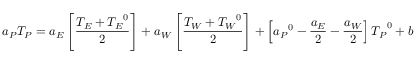Convert formula to latex. <formula><loc_0><loc_0><loc_500><loc_500>a _ { P } T _ { P } = a _ { E } \left [ { \frac { T _ { E } + { T _ { E } } ^ { 0 } } { 2 } } \right ] + a _ { W } \left [ { \frac { T _ { W } + { T _ { W } } ^ { 0 } } { 2 } } \right ] + \left [ { a _ { P } } ^ { 0 } - { \frac { a _ { E } } { 2 } } - { \frac { a _ { W } } { 2 } } \right ] { T _ { P } } ^ { 0 } + b</formula> 